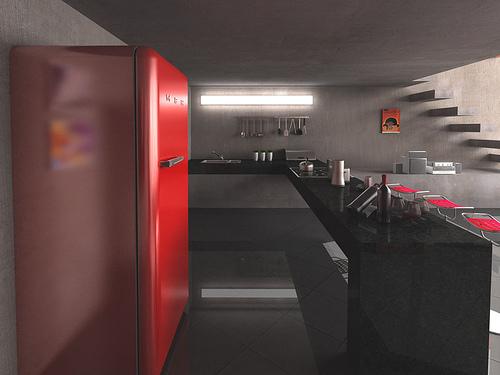How many full steps can you see?
Short answer required. 3. What is the color of the counter?
Keep it brief. Black. What color is the refrigerator?
Answer briefly. Red. 